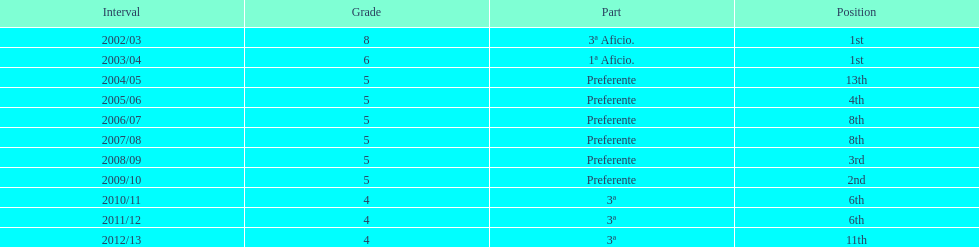How many times did internacional de madrid cf end the season at the top of their division? 2. Parse the table in full. {'header': ['Interval', 'Grade', 'Part', 'Position'], 'rows': [['2002/03', '8', '3ª Aficio.', '1st'], ['2003/04', '6', '1ª Aficio.', '1st'], ['2004/05', '5', 'Preferente', '13th'], ['2005/06', '5', 'Preferente', '4th'], ['2006/07', '5', 'Preferente', '8th'], ['2007/08', '5', 'Preferente', '8th'], ['2008/09', '5', 'Preferente', '3rd'], ['2009/10', '5', 'Preferente', '2nd'], ['2010/11', '4', '3ª', '6th'], ['2011/12', '4', '3ª', '6th'], ['2012/13', '4', '3ª', '11th']]} 